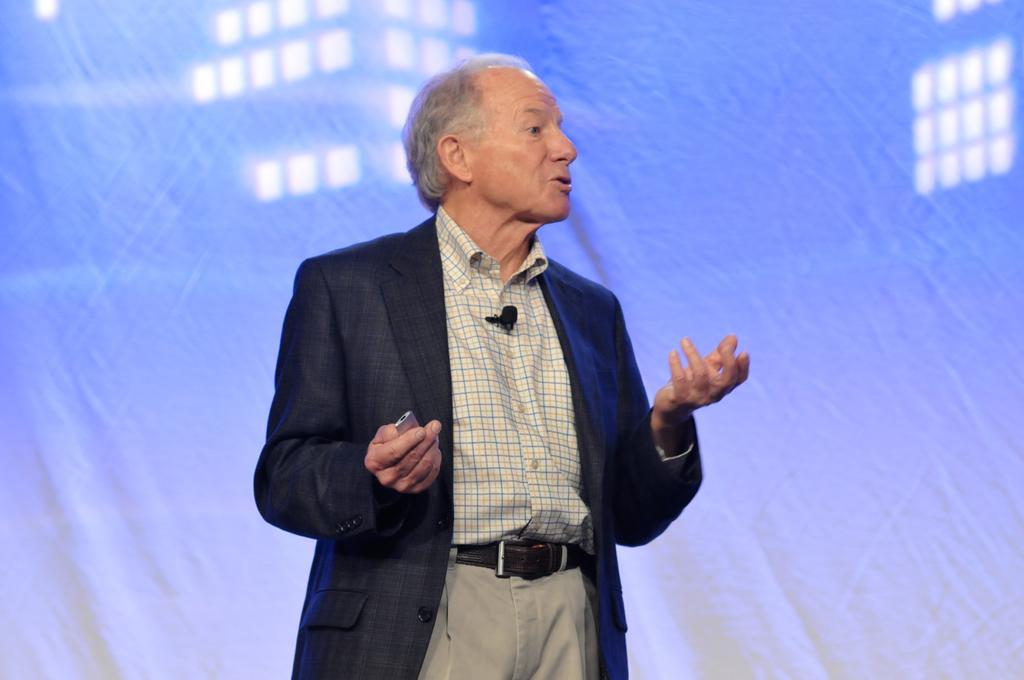In one or two sentences, can you explain what this image depicts? In the picture we can see a man standing and talking, he is in a black color blazer. 